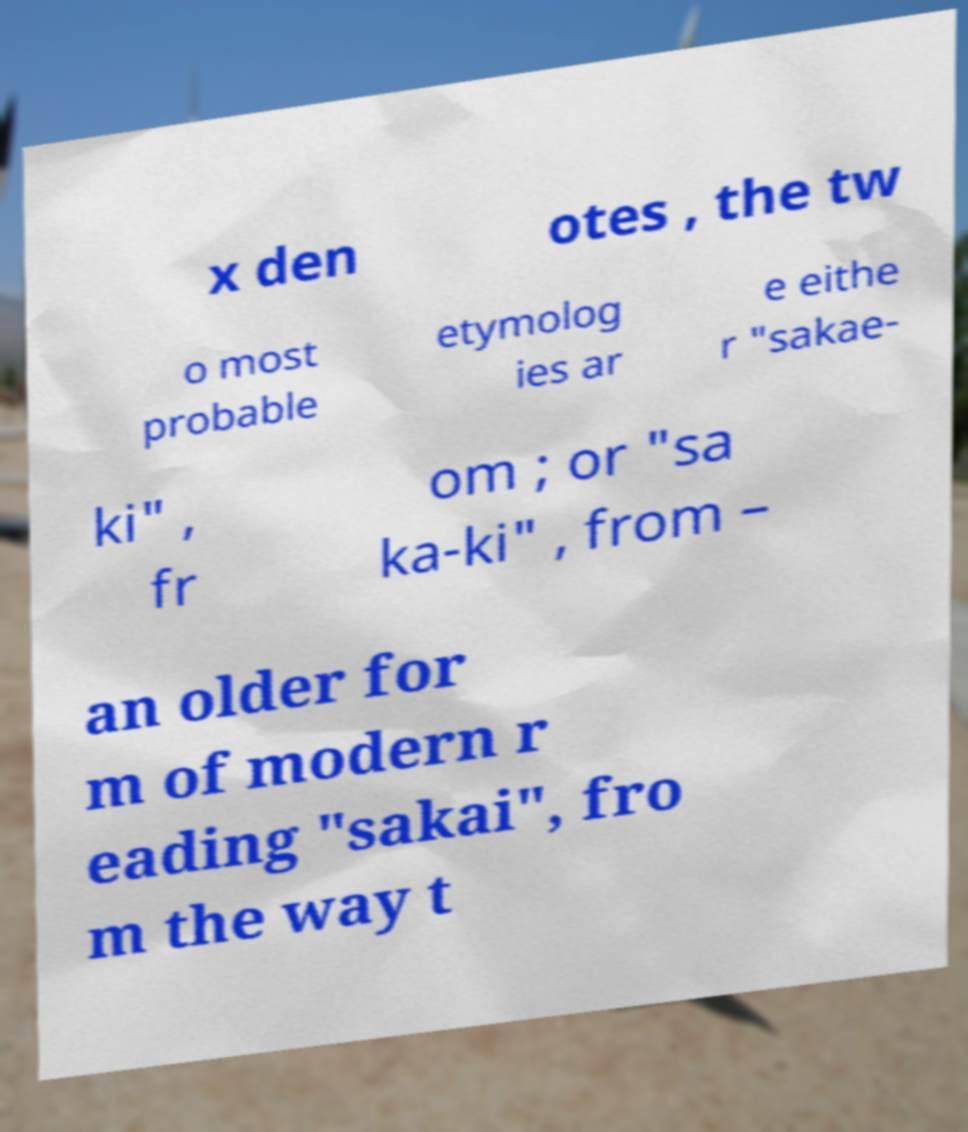Could you assist in decoding the text presented in this image and type it out clearly? x den otes , the tw o most probable etymolog ies ar e eithe r "sakae- ki" , fr om ; or "sa ka-ki" , from – an older for m of modern r eading "sakai", fro m the way t 